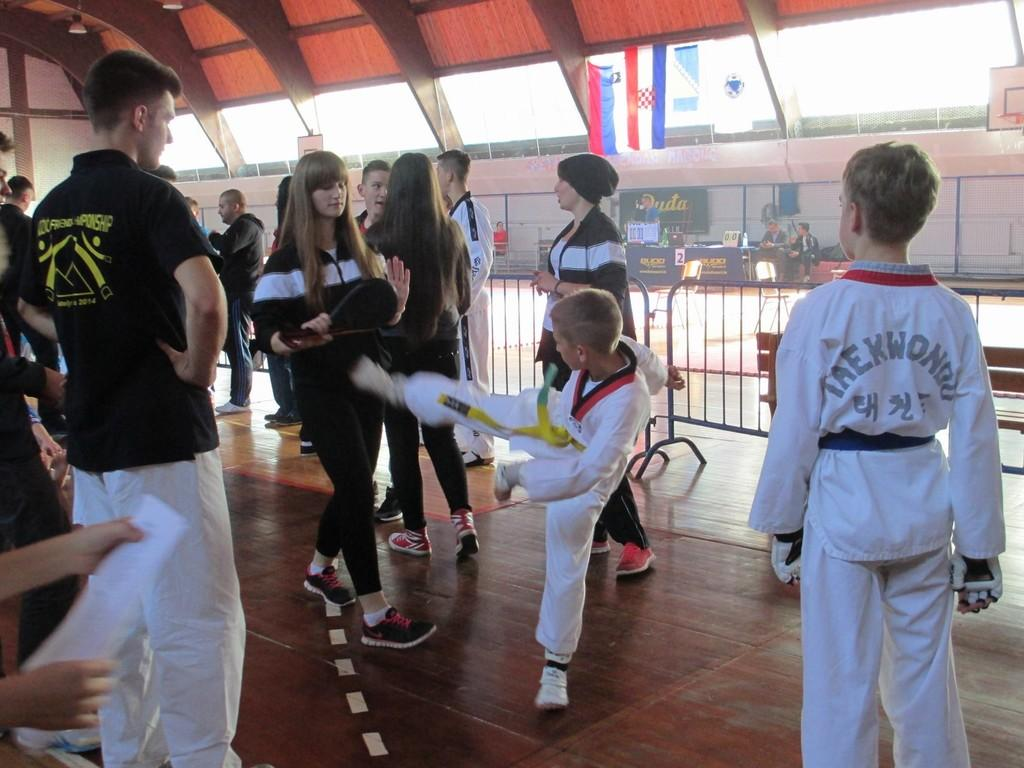<image>
Share a concise interpretation of the image provided. Young boys in a martial arts studio wear taekwondo uniforms. 